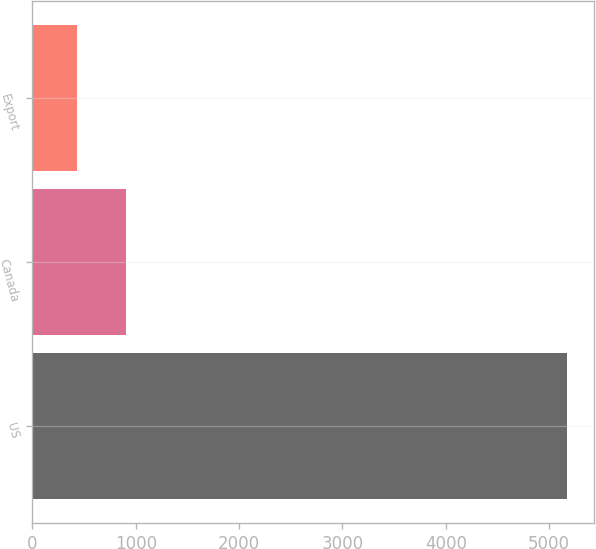<chart> <loc_0><loc_0><loc_500><loc_500><bar_chart><fcel>US<fcel>Canada<fcel>Export<nl><fcel>5175.9<fcel>904.5<fcel>429.9<nl></chart> 